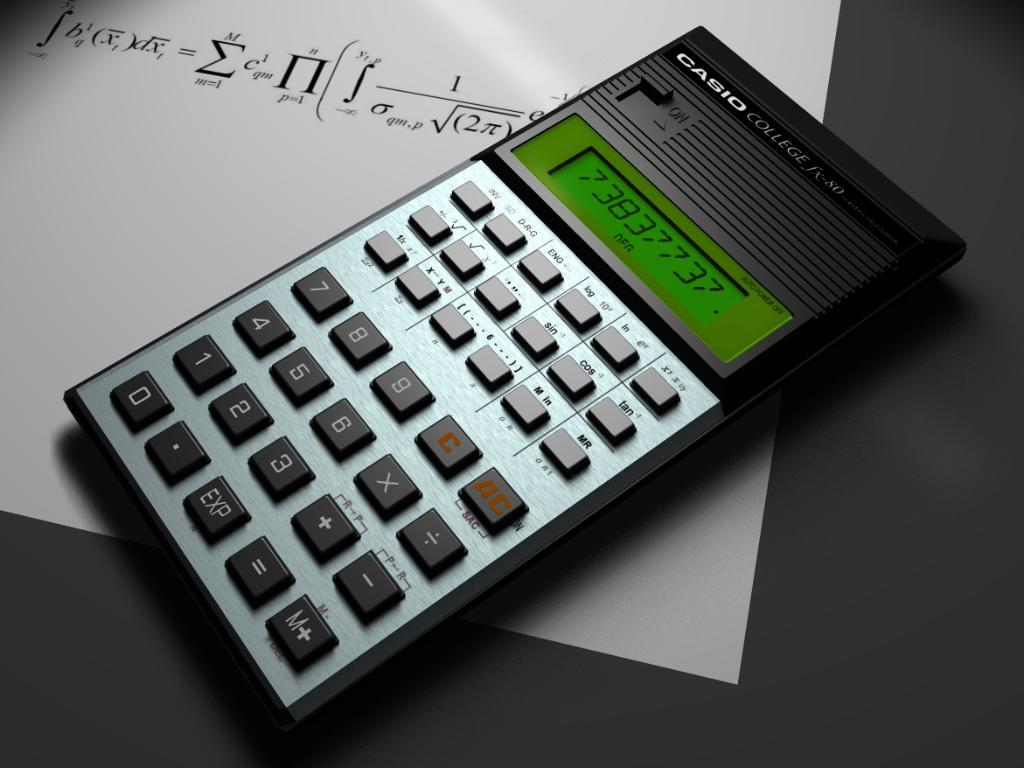<image>
Relay a brief, clear account of the picture shown. Black and silver calculator from CASIO on top of a paper. 